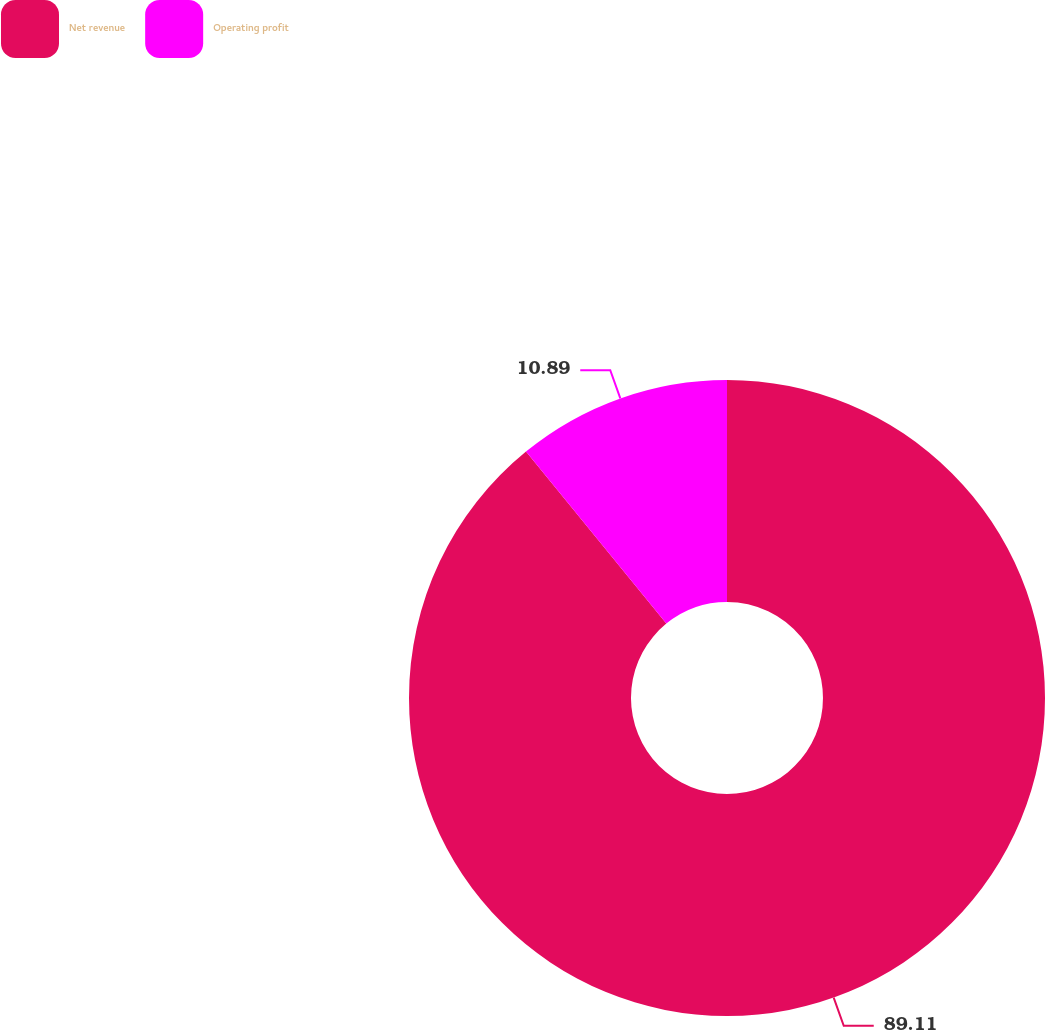Convert chart. <chart><loc_0><loc_0><loc_500><loc_500><pie_chart><fcel>Net revenue<fcel>Operating profit<nl><fcel>89.11%<fcel>10.89%<nl></chart> 